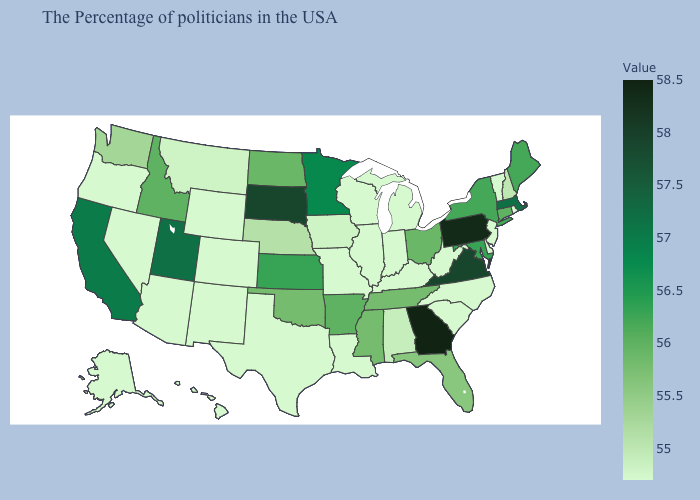Among the states that border Massachusetts , which have the lowest value?
Give a very brief answer. Rhode Island, Vermont. Among the states that border South Dakota , does Minnesota have the highest value?
Give a very brief answer. Yes. Is the legend a continuous bar?
Answer briefly. Yes. Which states have the highest value in the USA?
Give a very brief answer. Georgia. Does Florida have the lowest value in the South?
Concise answer only. No. Does Michigan have the lowest value in the USA?
Be succinct. Yes. Does Tennessee have the lowest value in the South?
Keep it brief. No. 